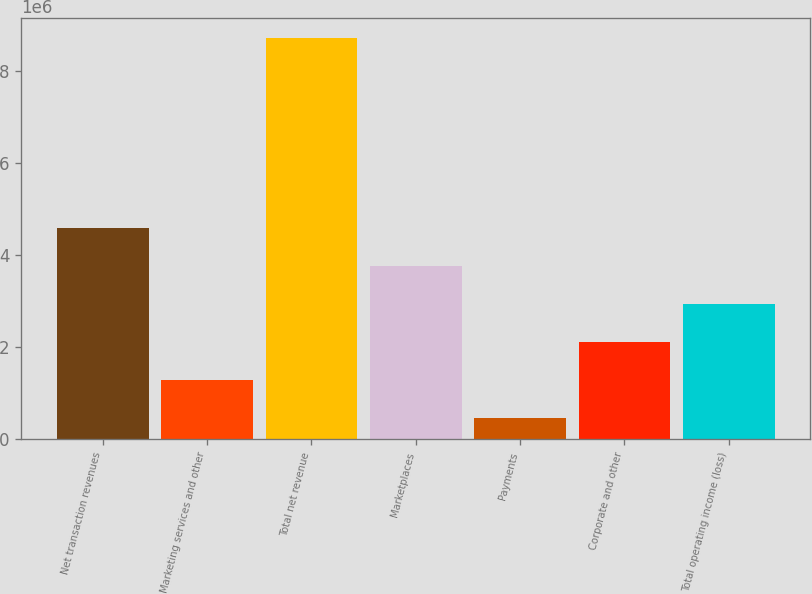Convert chart to OTSL. <chart><loc_0><loc_0><loc_500><loc_500><bar_chart><fcel>Net transaction revenues<fcel>Marketing services and other<fcel>Total net revenue<fcel>Marketplaces<fcel>Payments<fcel>Corporate and other<fcel>Total operating income (loss)<nl><fcel>4.59537e+06<fcel>1.28978e+06<fcel>8.72736e+06<fcel>3.76897e+06<fcel>463382<fcel>2.11618e+06<fcel>2.94258e+06<nl></chart> 